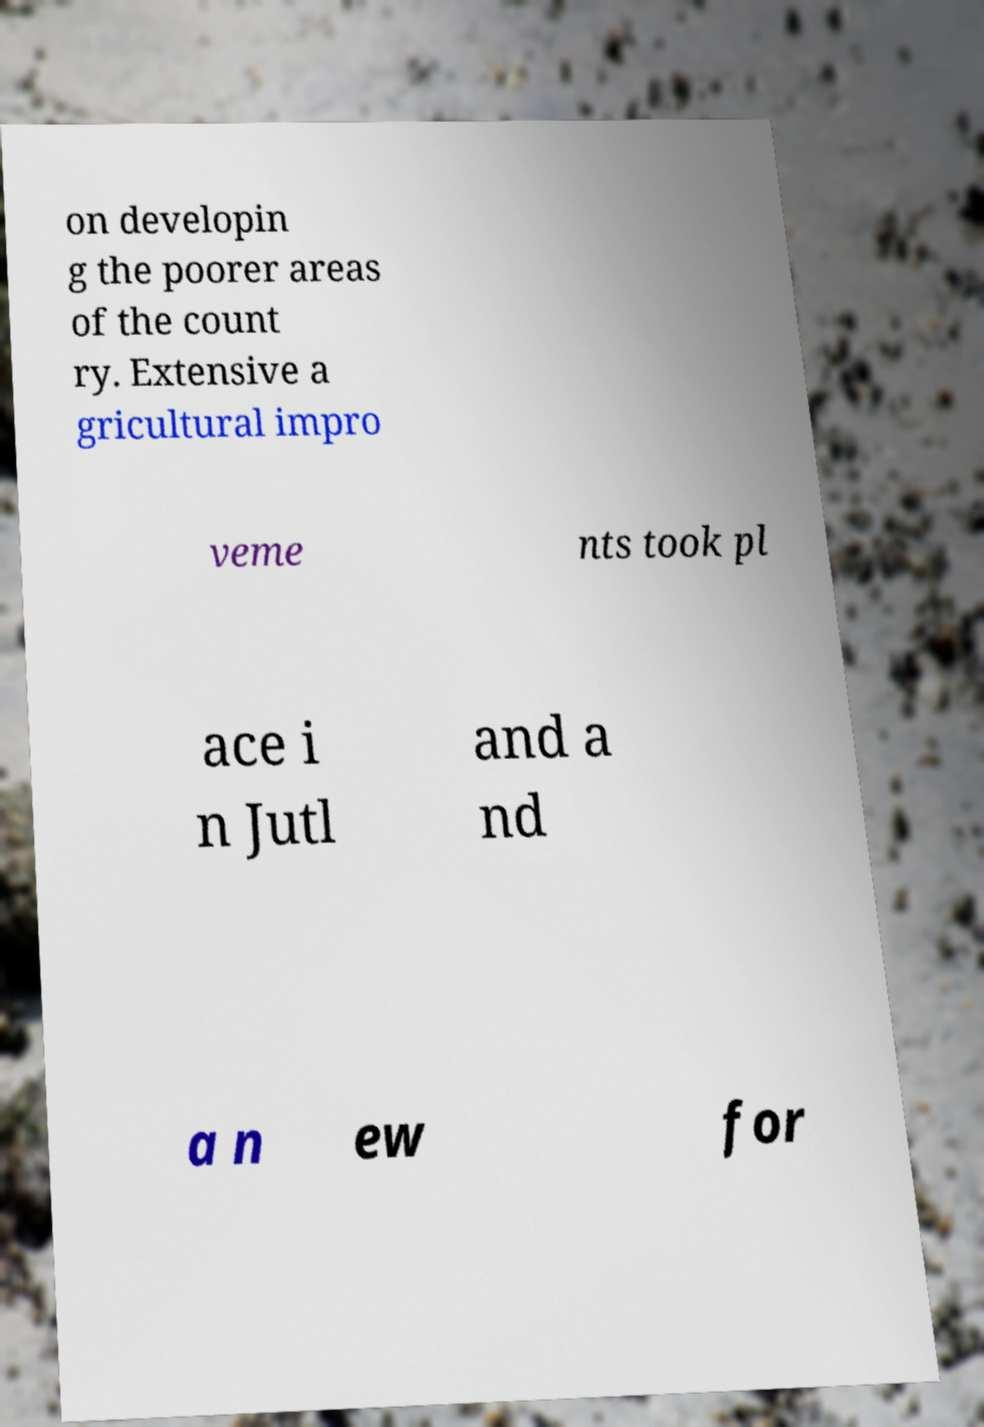Can you read and provide the text displayed in the image?This photo seems to have some interesting text. Can you extract and type it out for me? on developin g the poorer areas of the count ry. Extensive a gricultural impro veme nts took pl ace i n Jutl and a nd a n ew for 